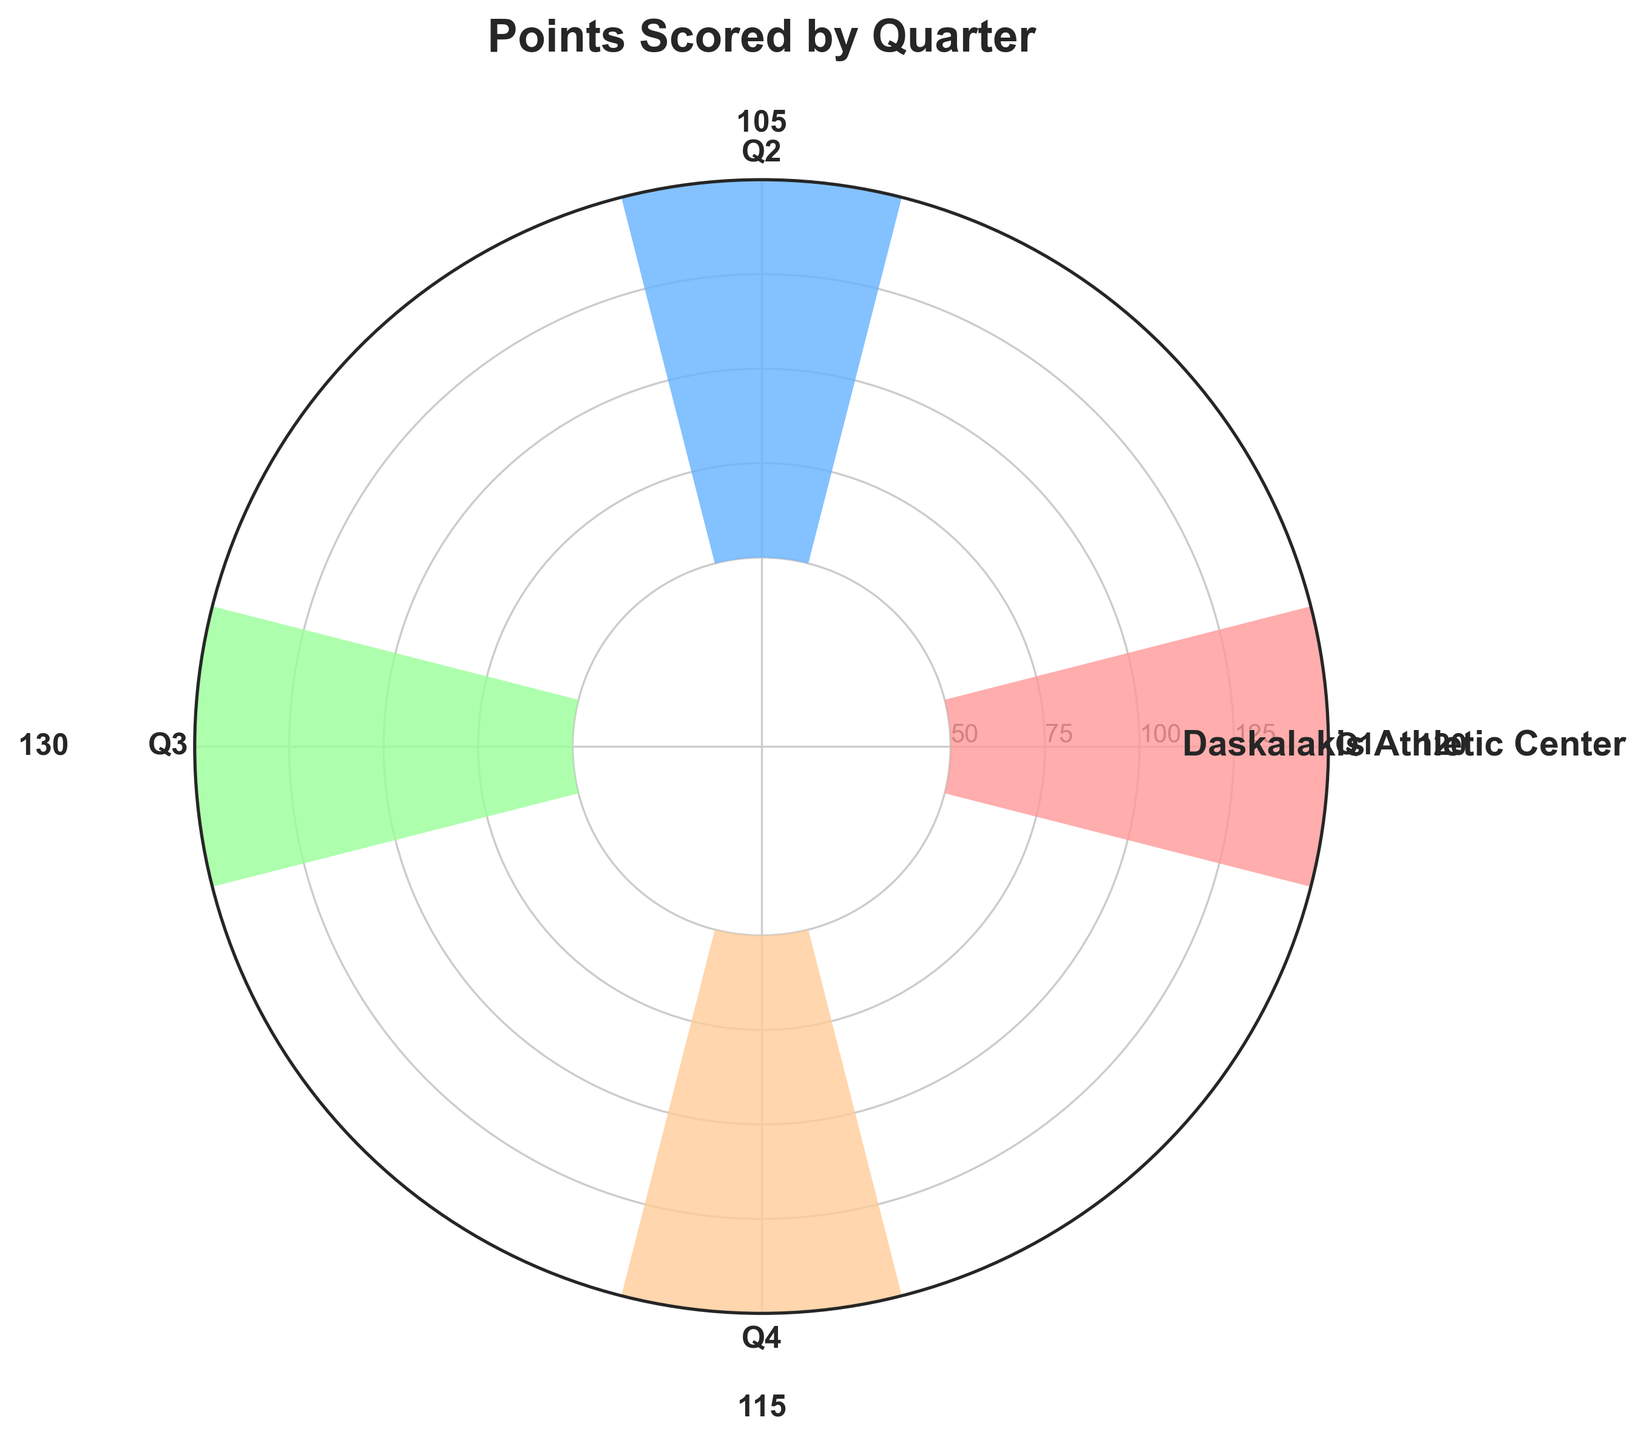What's the title of the plot? The title is located at the top center of the plot, which reads "Points Scored by Quarter".
Answer: Points Scored by Quarter How many quarters are represented in the plot? The four sections visible on the plot represent the four quarters, indicated as Q1, Q2, Q3, and Q4 along the circular axis.
Answer: 4 Which quarter saw the highest points scored? By comparing the bar heights, it's evident that Q3 has the tallest bar, indicating the highest points scored among the four quarters.
Answer: Q3 What is the total number of points scored across all quarters? Sum the points from each quarter: 120 (Q1) + 105 (Q2) + 130 (Q3) + 115 (Q4), leading to a total of 470 points.
Answer: 470 What's the difference in points scored between the highest and lowest quarters? The highest points scored are in Q3 (130), and the lowest are in Q2 (105). The difference is: 130 - 105 = 25 points.
Answer: 25 Which quarter had the lowest points, and what was the value? By observing the bars, Q2 is the shortest, indicating it had the lowest points scored, which is confirmed to be 105 points.
Answer: Q2, 105 What is the average number of points scored per quarter? Sum up the points of all quarters and divide by the number of quarters: (120 + 105 + 130 + 115) / 4 = 470 / 4 = 117.5 points.
Answer: 117.5 By how many points does Q1 exceed Q2? Subtract the points scored in Q2 from those in Q1: 120 (Q1) - 105 (Q2) = 15 points.
Answer: 15 What range of points does the plot cover along the radial axis? The plot starts at around 50 points and extends to just past 130 points, based on the scale and the highest bar.
Answer: 50 to 135 points 